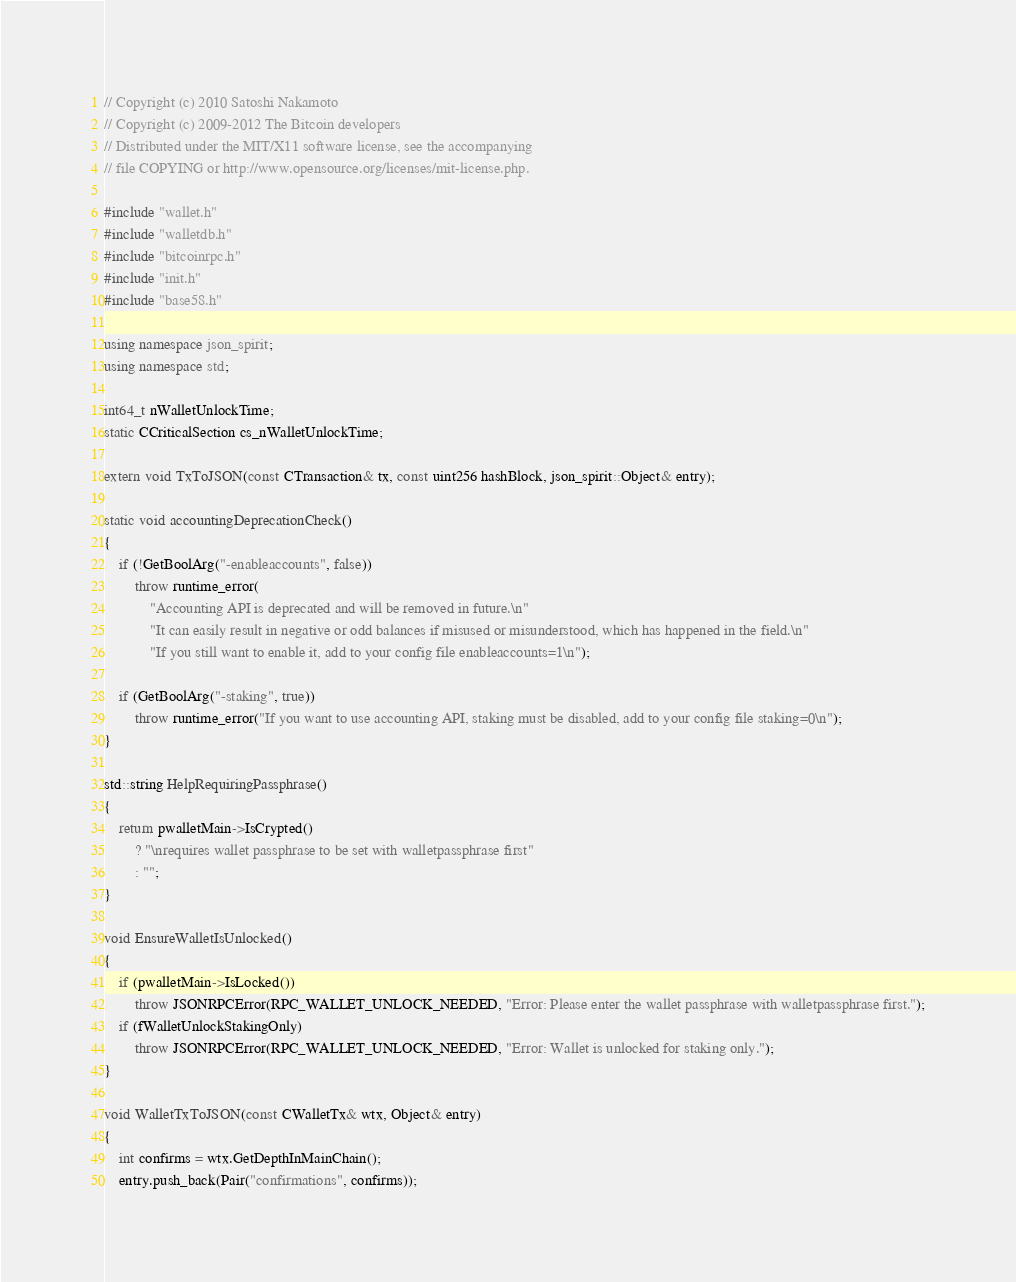<code> <loc_0><loc_0><loc_500><loc_500><_C++_>// Copyright (c) 2010 Satoshi Nakamoto
// Copyright (c) 2009-2012 The Bitcoin developers
// Distributed under the MIT/X11 software license, see the accompanying
// file COPYING or http://www.opensource.org/licenses/mit-license.php.

#include "wallet.h"
#include "walletdb.h"
#include "bitcoinrpc.h"
#include "init.h"
#include "base58.h"

using namespace json_spirit;
using namespace std;

int64_t nWalletUnlockTime;
static CCriticalSection cs_nWalletUnlockTime;

extern void TxToJSON(const CTransaction& tx, const uint256 hashBlock, json_spirit::Object& entry);

static void accountingDeprecationCheck()
{
    if (!GetBoolArg("-enableaccounts", false))
        throw runtime_error(
            "Accounting API is deprecated and will be removed in future.\n"
            "It can easily result in negative or odd balances if misused or misunderstood, which has happened in the field.\n"
            "If you still want to enable it, add to your config file enableaccounts=1\n");

    if (GetBoolArg("-staking", true))
        throw runtime_error("If you want to use accounting API, staking must be disabled, add to your config file staking=0\n");
}

std::string HelpRequiringPassphrase()
{
    return pwalletMain->IsCrypted()
        ? "\nrequires wallet passphrase to be set with walletpassphrase first"
        : "";
}

void EnsureWalletIsUnlocked()
{
    if (pwalletMain->IsLocked())
        throw JSONRPCError(RPC_WALLET_UNLOCK_NEEDED, "Error: Please enter the wallet passphrase with walletpassphrase first.");
    if (fWalletUnlockStakingOnly)
        throw JSONRPCError(RPC_WALLET_UNLOCK_NEEDED, "Error: Wallet is unlocked for staking only.");
}

void WalletTxToJSON(const CWalletTx& wtx, Object& entry)
{
    int confirms = wtx.GetDepthInMainChain();
    entry.push_back(Pair("confirmations", confirms));</code> 